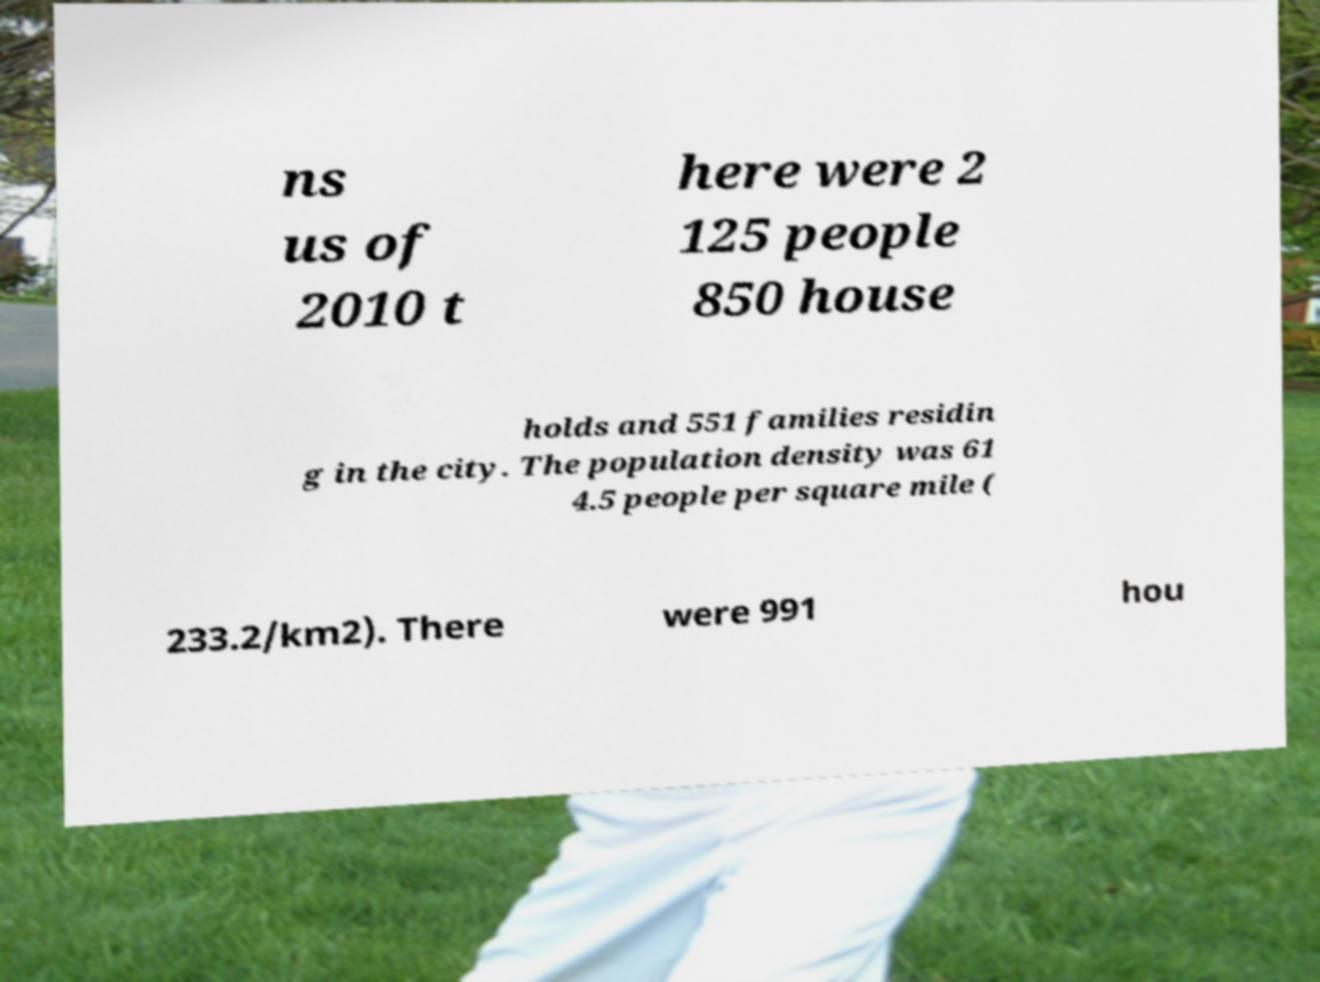Could you extract and type out the text from this image? ns us of 2010 t here were 2 125 people 850 house holds and 551 families residin g in the city. The population density was 61 4.5 people per square mile ( 233.2/km2). There were 991 hou 